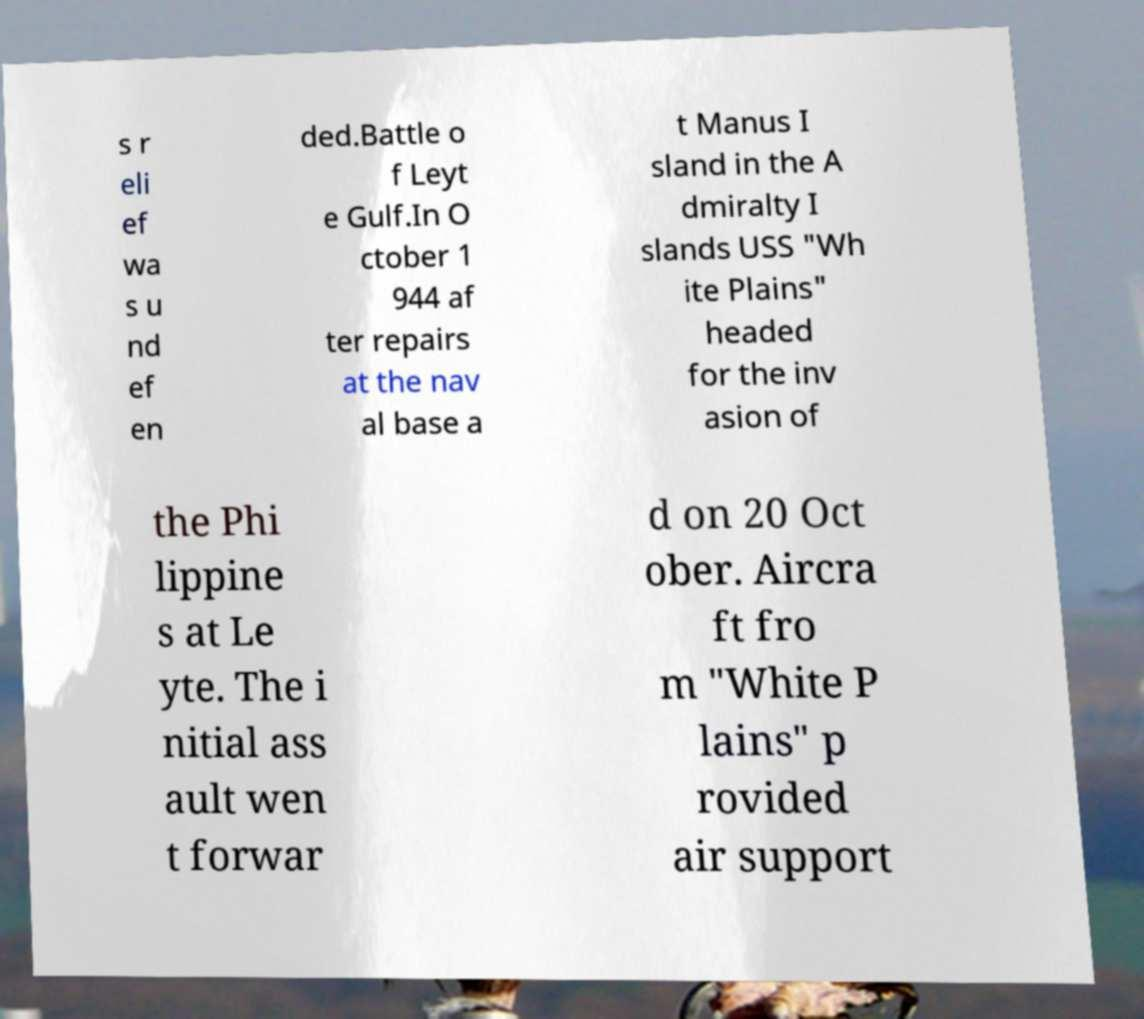What messages or text are displayed in this image? I need them in a readable, typed format. s r eli ef wa s u nd ef en ded.Battle o f Leyt e Gulf.In O ctober 1 944 af ter repairs at the nav al base a t Manus I sland in the A dmiralty I slands USS "Wh ite Plains" headed for the inv asion of the Phi lippine s at Le yte. The i nitial ass ault wen t forwar d on 20 Oct ober. Aircra ft fro m "White P lains" p rovided air support 